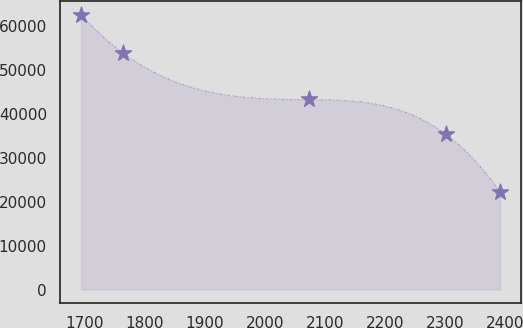Convert chart. <chart><loc_0><loc_0><loc_500><loc_500><line_chart><ecel><fcel>Unnamed: 1<nl><fcel>1693.87<fcel>62673<nl><fcel>1763.62<fcel>53945.5<nl><fcel>2073.92<fcel>43340.9<nl><fcel>2301.74<fcel>35357.2<nl><fcel>2391.38<fcel>22196.2<nl></chart> 